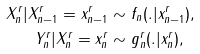Convert formula to latex. <formula><loc_0><loc_0><loc_500><loc_500>X _ { n } ^ { r } | X _ { n - 1 } ^ { r } = x _ { n - 1 } ^ { r } & \sim f _ { n } ( . | x _ { n - 1 } ^ { r } ) , \\ Y _ { n } ^ { r } | X _ { n } ^ { r } = x _ { n } ^ { r } & \sim g _ { n } ^ { r } ( . | x _ { n } ^ { r } ) ,</formula> 